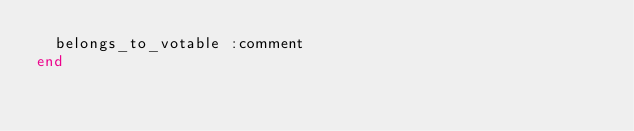Convert code to text. <code><loc_0><loc_0><loc_500><loc_500><_Ruby_>  belongs_to_votable :comment
end
</code> 